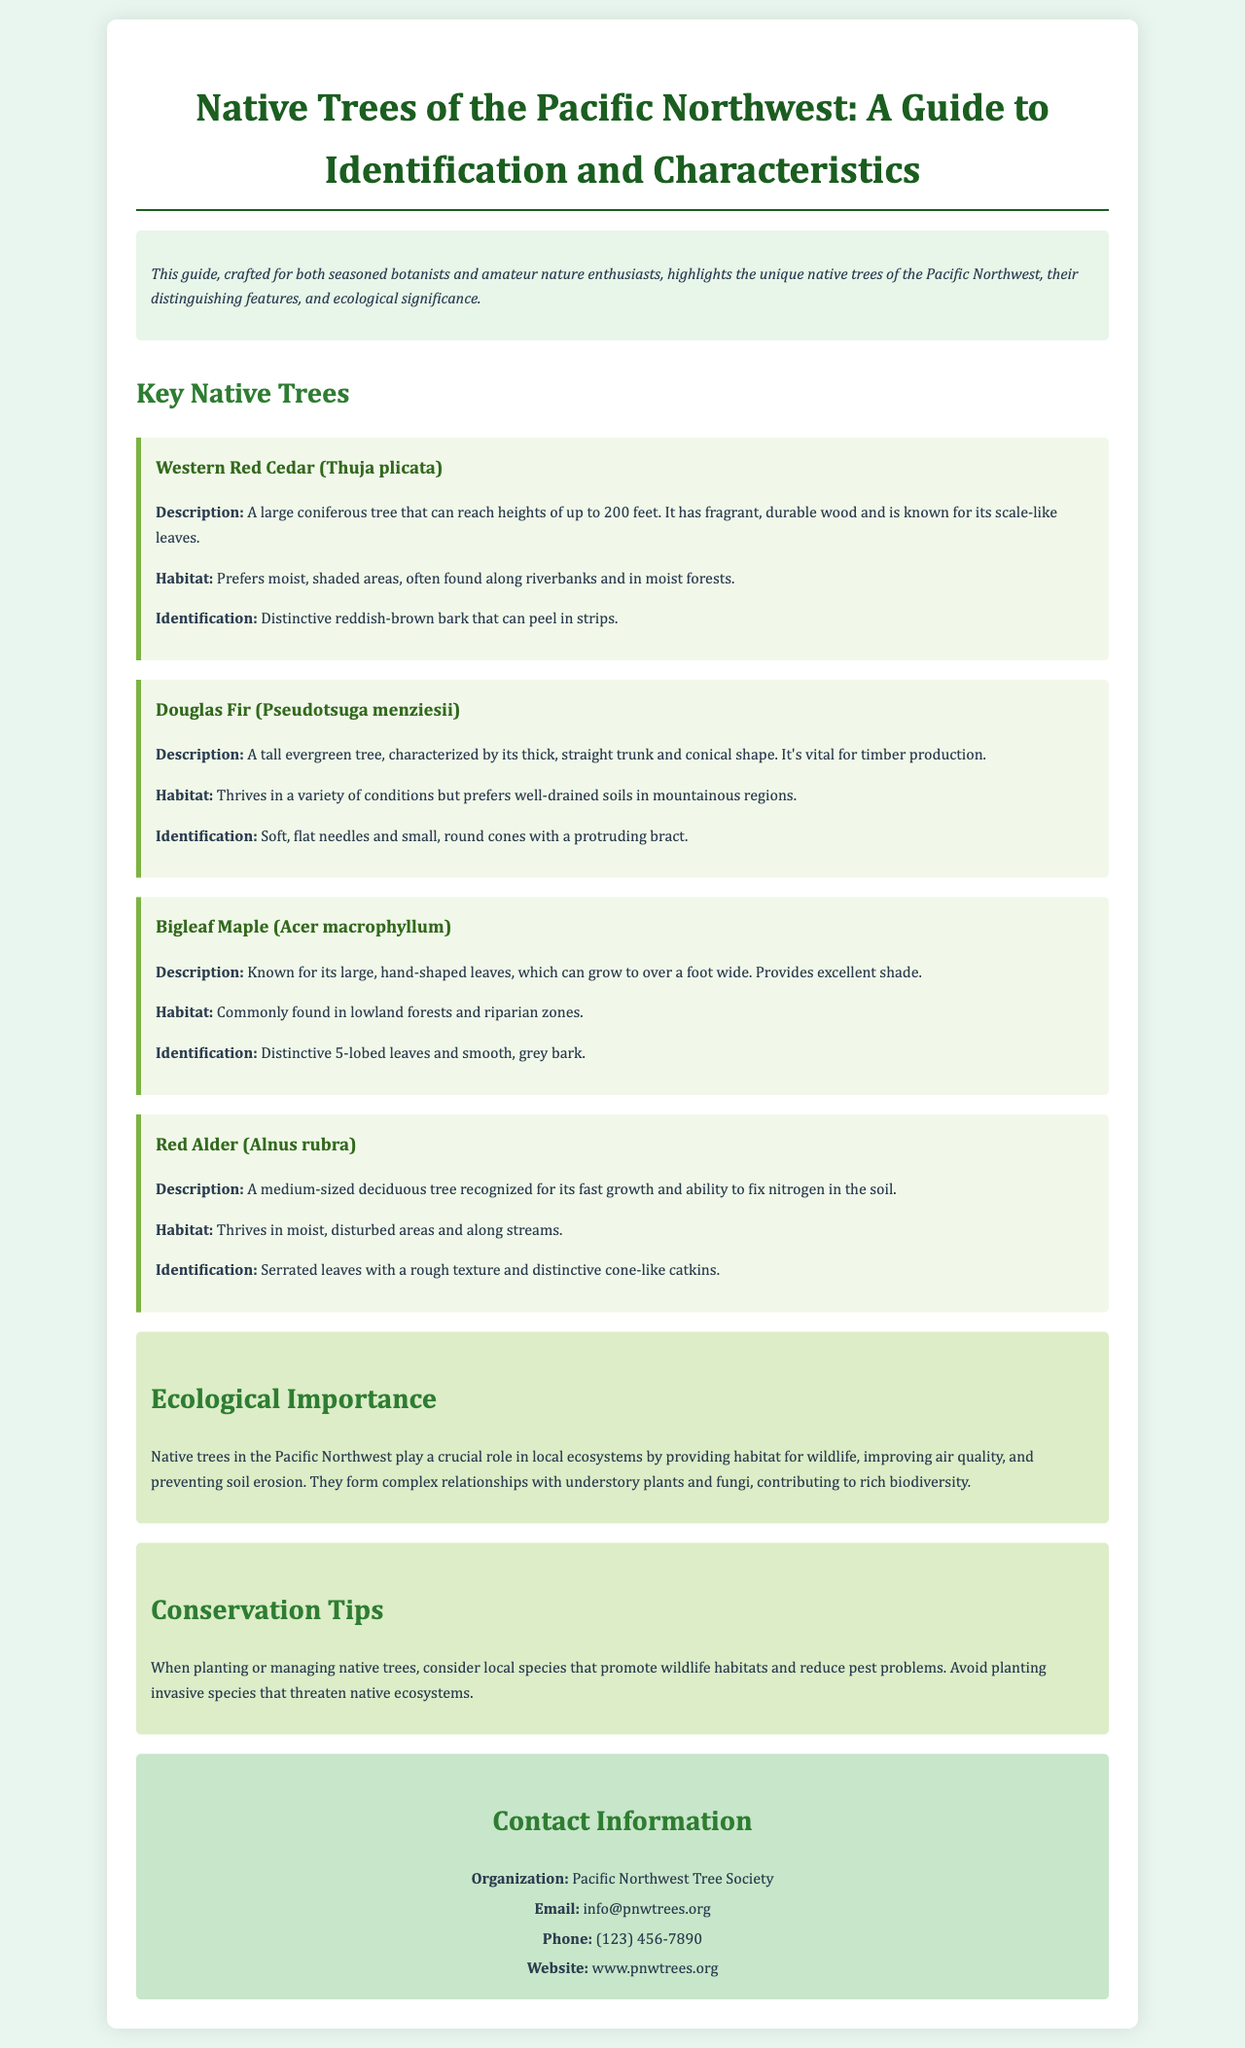What is the title of the brochure? The title of the brochure is prominently displayed at the top, indicating the subject matter it covers.
Answer: Native Trees of the Pacific Northwest: A Guide to Identification and Characteristics Which organization is mentioned in the contact information? The document provides a specific organization that is responsible for the guide, found in the contact section.
Answer: Pacific Northwest Tree Society How tall can the Western Red Cedar grow? The document specifies the maximum height of this tree in the description section.
Answer: up to 200 feet What type of tree is the Bigleaf Maple? The description section classifies this tree, indicating its leaf characteristics and growth form.
Answer: Deciduous tree What ecological role do native trees play in the Pacific Northwest? The ecological importance section highlights the contributions of these trees to the environment.
Answer: Providing habitat for wildlife What should be avoided when planting native trees? The conservation tips section advises against certain practices that could harm local ecosystems.
Answer: Planting invasive species 